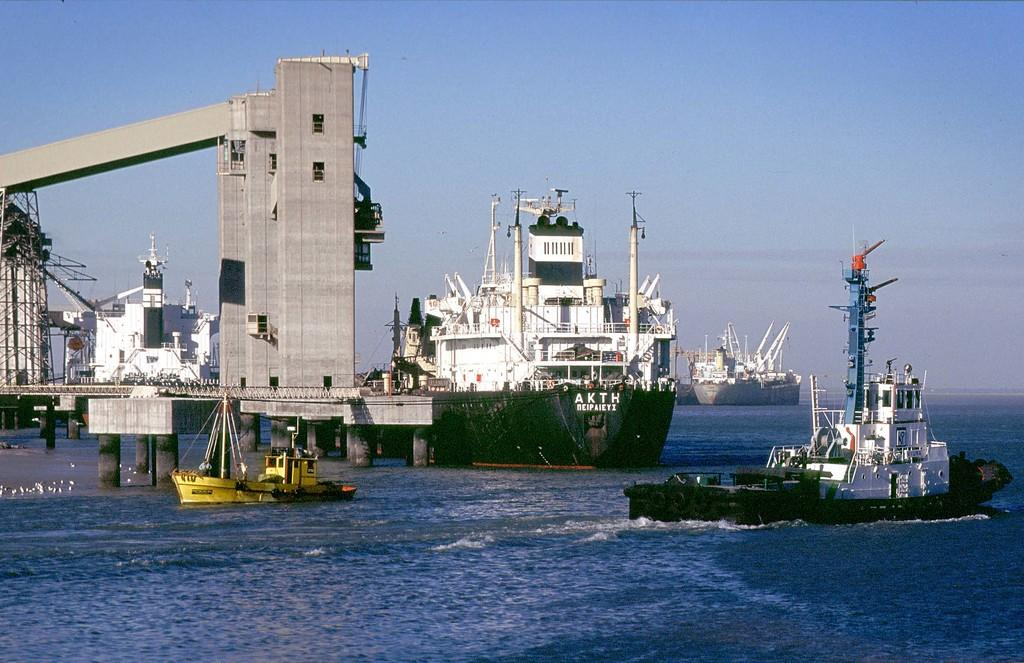<image>
Give a short and clear explanation of the subsequent image. A bunch of ships are in a harbor, one with the initials AKTH. 